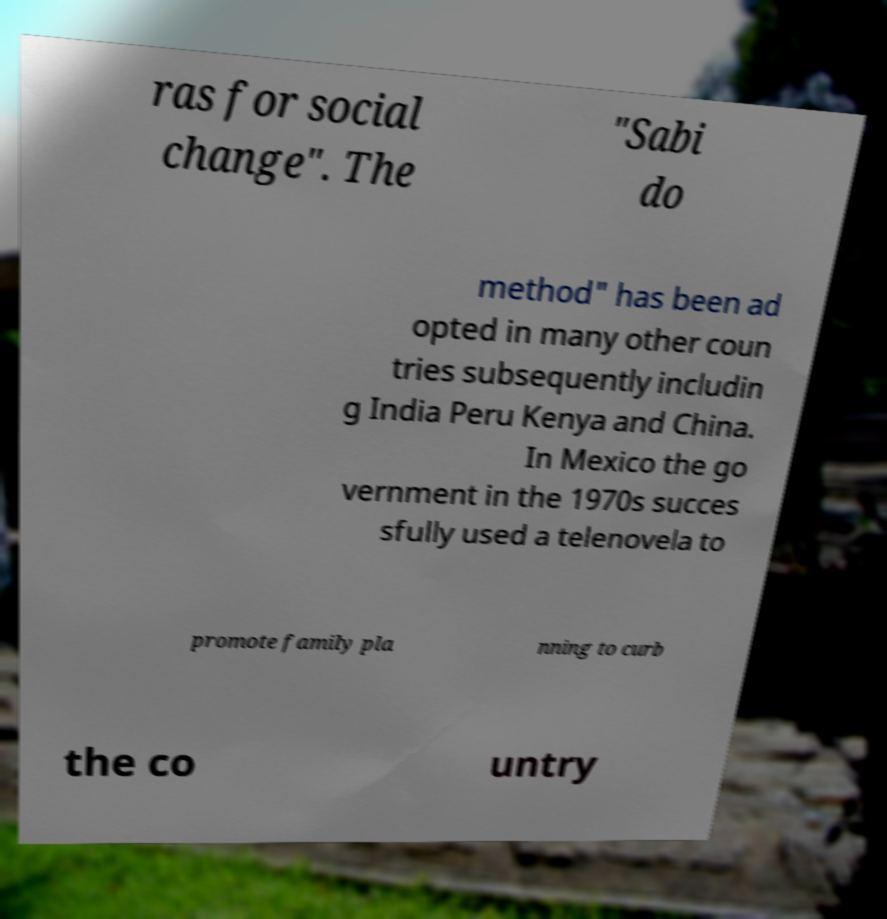Can you accurately transcribe the text from the provided image for me? ras for social change". The "Sabi do method" has been ad opted in many other coun tries subsequently includin g India Peru Kenya and China. In Mexico the go vernment in the 1970s succes sfully used a telenovela to promote family pla nning to curb the co untry 